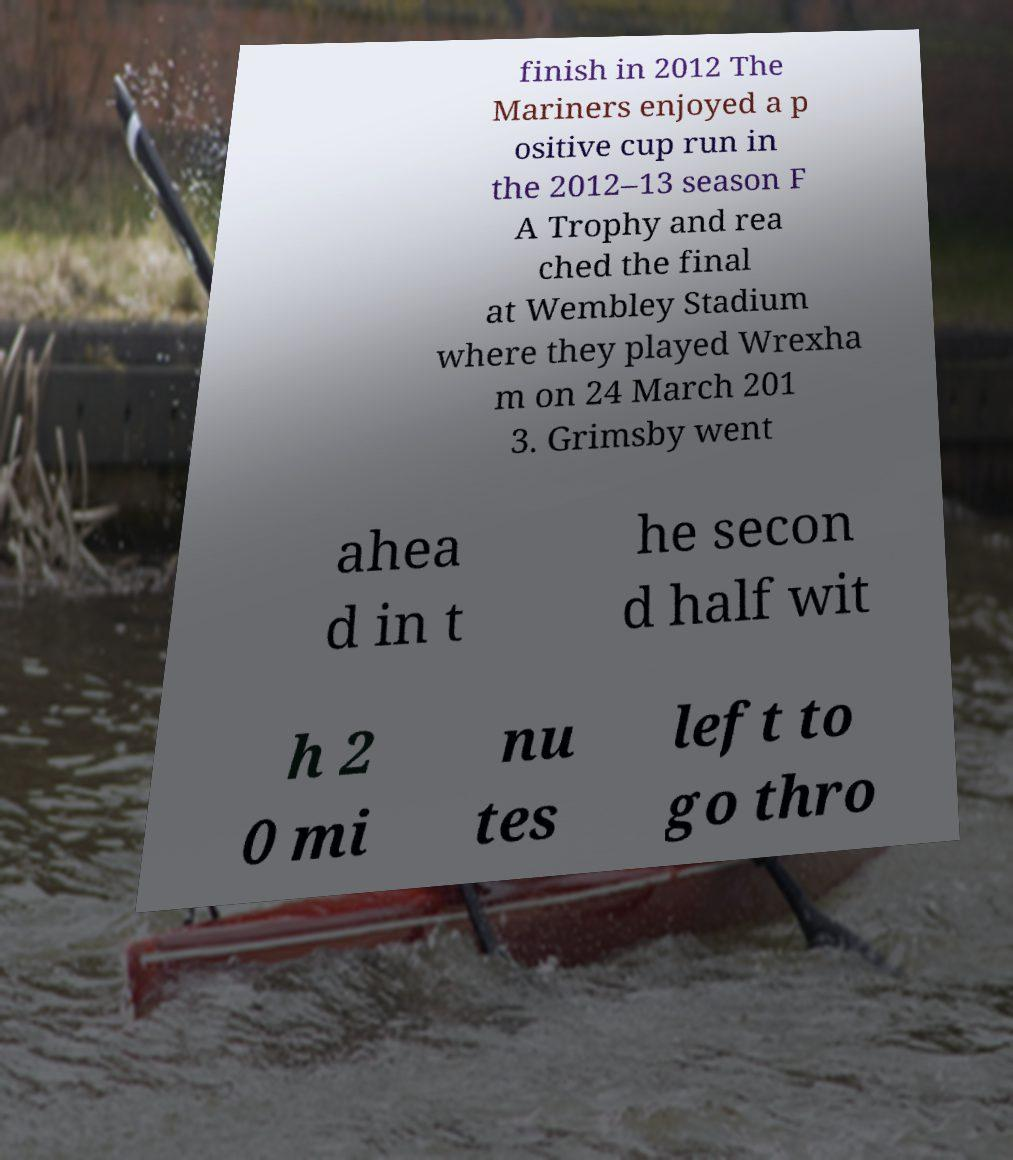Could you assist in decoding the text presented in this image and type it out clearly? finish in 2012 The Mariners enjoyed a p ositive cup run in the 2012–13 season F A Trophy and rea ched the final at Wembley Stadium where they played Wrexha m on 24 March 201 3. Grimsby went ahea d in t he secon d half wit h 2 0 mi nu tes left to go thro 